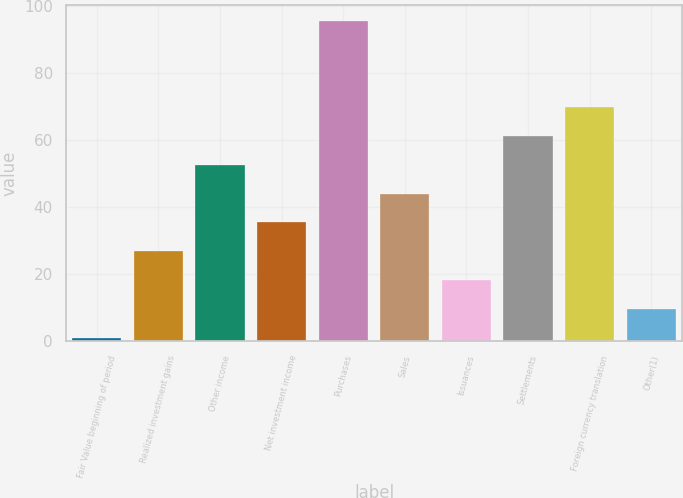Convert chart. <chart><loc_0><loc_0><loc_500><loc_500><bar_chart><fcel>Fair Value beginning of period<fcel>Realized investment gains<fcel>Other income<fcel>Net investment income<fcel>Purchases<fcel>Sales<fcel>Issuances<fcel>Settlements<fcel>Foreign currency translation<fcel>Other(1)<nl><fcel>1<fcel>26.8<fcel>52.6<fcel>35.4<fcel>95.6<fcel>44<fcel>18.2<fcel>61.2<fcel>69.8<fcel>9.6<nl></chart> 